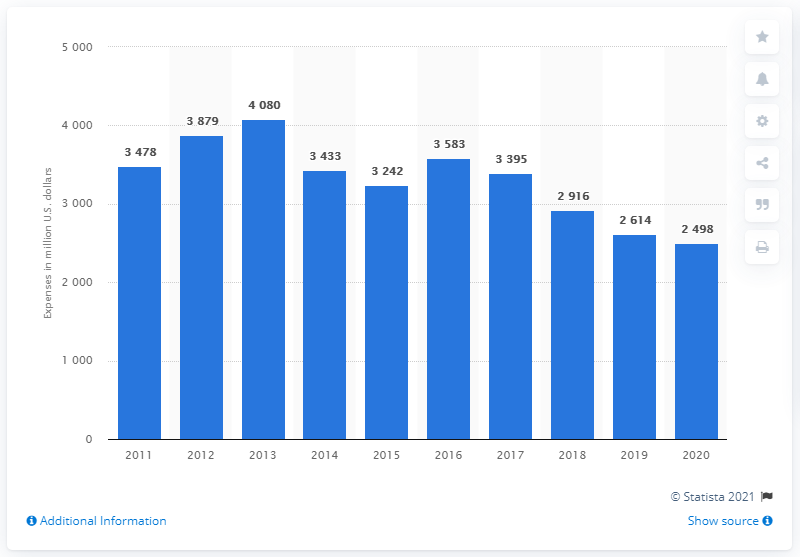Draw attention to some important aspects in this diagram. According to the information available, Teva Pharmaceutical Industries spent approximately 2498 on marketing and selling in 2020. 